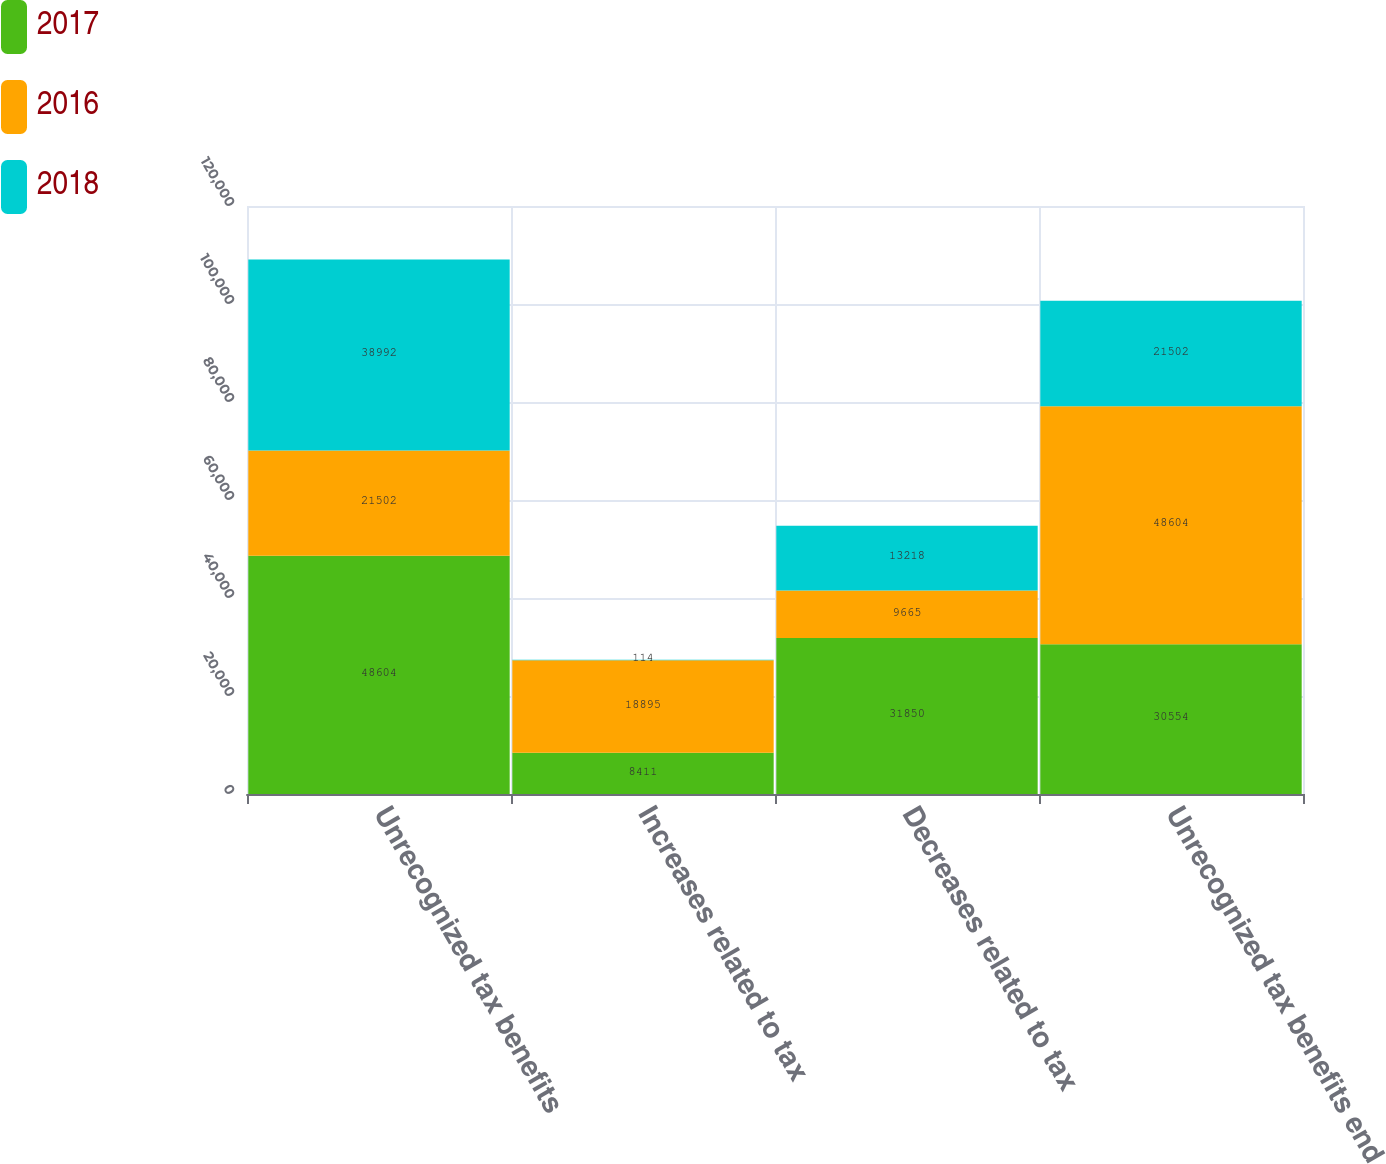Convert chart to OTSL. <chart><loc_0><loc_0><loc_500><loc_500><stacked_bar_chart><ecel><fcel>Unrecognized tax benefits<fcel>Increases related to tax<fcel>Decreases related to tax<fcel>Unrecognized tax benefits end<nl><fcel>2017<fcel>48604<fcel>8411<fcel>31850<fcel>30554<nl><fcel>2016<fcel>21502<fcel>18895<fcel>9665<fcel>48604<nl><fcel>2018<fcel>38992<fcel>114<fcel>13218<fcel>21502<nl></chart> 